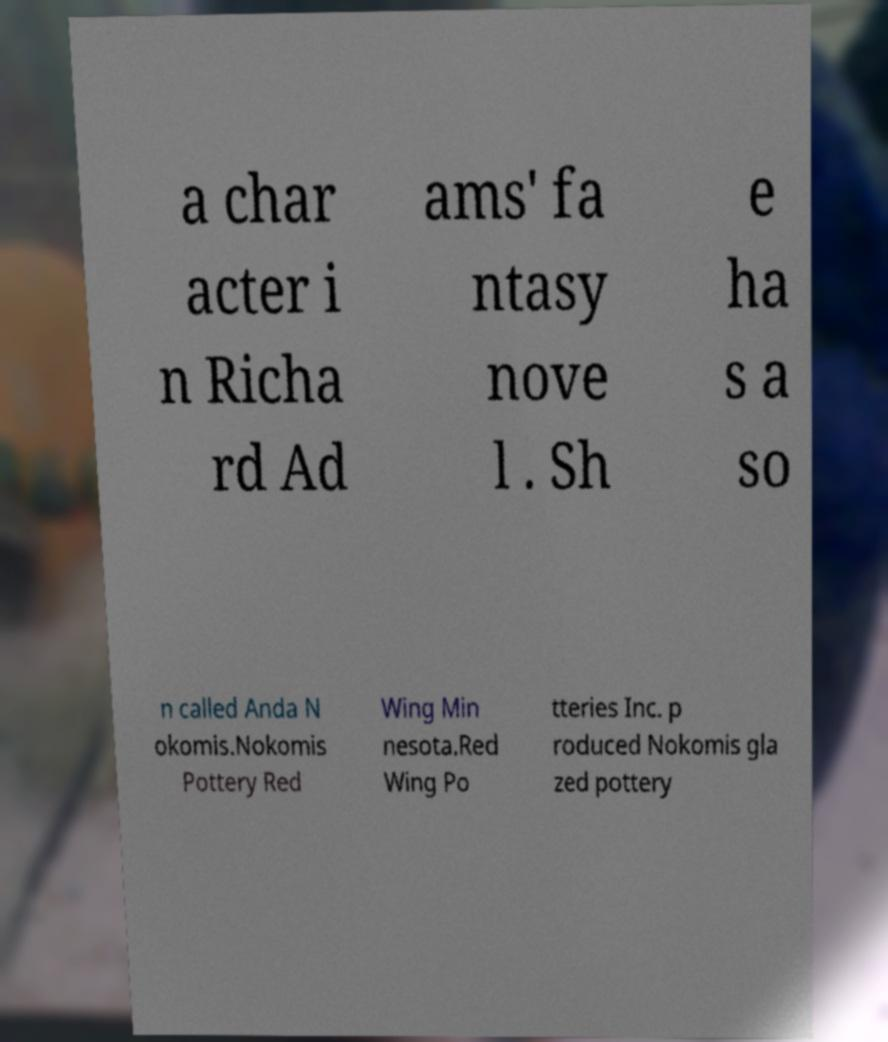Could you assist in decoding the text presented in this image and type it out clearly? a char acter i n Richa rd Ad ams' fa ntasy nove l . Sh e ha s a so n called Anda N okomis.Nokomis Pottery Red Wing Min nesota.Red Wing Po tteries Inc. p roduced Nokomis gla zed pottery 